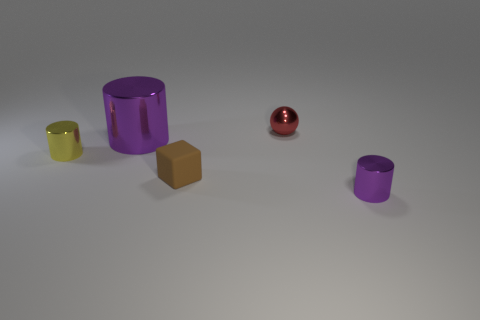What number of other small objects are the same color as the small matte thing?
Ensure brevity in your answer.  0. Do the purple metal object that is behind the tiny purple thing and the yellow object have the same shape?
Your answer should be compact. Yes. The metal thing that is to the left of the purple metal cylinder that is behind the purple metallic object right of the tiny rubber cube is what shape?
Your response must be concise. Cylinder. What size is the brown block?
Provide a succinct answer. Small. There is a big object that is the same material as the tiny sphere; what color is it?
Your response must be concise. Purple. How many tiny purple things have the same material as the big purple thing?
Ensure brevity in your answer.  1. There is a metallic sphere; is its color the same as the small metallic cylinder that is behind the small purple cylinder?
Keep it short and to the point. No. There is a small shiny cylinder in front of the small metal object that is to the left of the tiny rubber block; what color is it?
Ensure brevity in your answer.  Purple. There is a rubber cube that is the same size as the red ball; what is its color?
Keep it short and to the point. Brown. Are there any other large metal objects that have the same shape as the red thing?
Your response must be concise. No. 